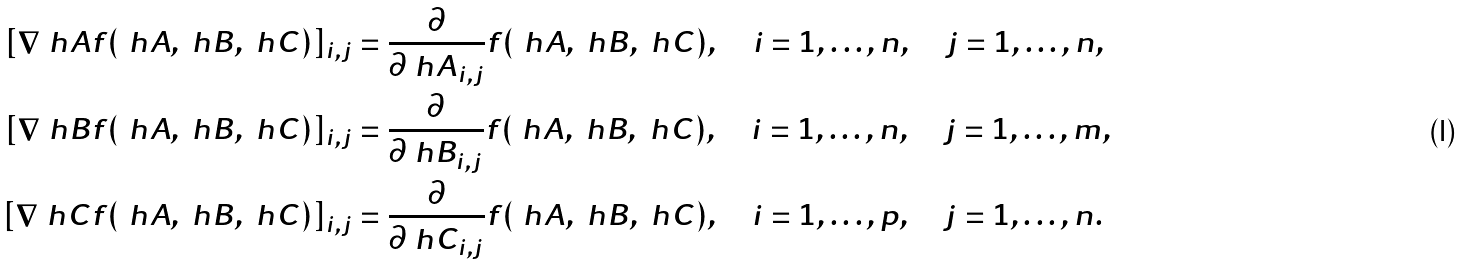Convert formula to latex. <formula><loc_0><loc_0><loc_500><loc_500>[ \nabla _ { \ } h A f ( \ h A , \ h B , \ h C ) ] _ { i , j } & = \frac { \partial } { \partial \ h A _ { i , j } } f ( \ h A , \ h B , \ h C ) , \quad i = 1 , \dots , n , \quad j = 1 , \dots , n , \\ [ \nabla _ { \ } h B f ( \ h A , \ h B , \ h C ) ] _ { i , j } & = \frac { \partial } { \partial \ h B _ { i , j } } f ( \ h A , \ h B , \ h C ) , \quad i = 1 , \dots , n , \quad j = 1 , \dots , m , \\ [ \nabla _ { \ } h C f ( \ h A , \ h B , \ h C ) ] _ { i , j } & = \frac { \partial } { \partial \ h C _ { i , j } } f ( \ h A , \ h B , \ h C ) , \quad i = 1 , \dots , p , \quad j = 1 , \dots , n .</formula> 